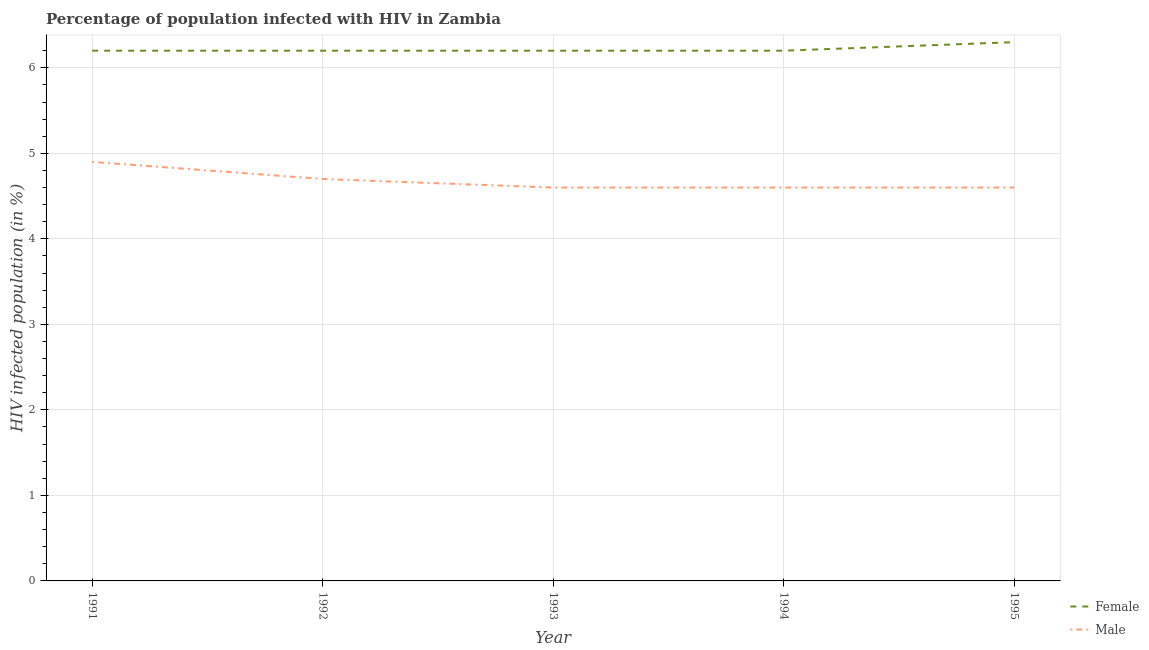How many different coloured lines are there?
Ensure brevity in your answer.  2. Does the line corresponding to percentage of females who are infected with hiv intersect with the line corresponding to percentage of males who are infected with hiv?
Your answer should be very brief. No. Is the number of lines equal to the number of legend labels?
Your answer should be compact. Yes. Across all years, what is the maximum percentage of females who are infected with hiv?
Provide a short and direct response. 6.3. Across all years, what is the minimum percentage of females who are infected with hiv?
Your response must be concise. 6.2. In which year was the percentage of males who are infected with hiv maximum?
Keep it short and to the point. 1991. What is the total percentage of females who are infected with hiv in the graph?
Provide a succinct answer. 31.1. What is the difference between the percentage of males who are infected with hiv in 1992 and that in 1994?
Provide a succinct answer. 0.1. What is the difference between the percentage of females who are infected with hiv in 1992 and the percentage of males who are infected with hiv in 1995?
Provide a short and direct response. 1.6. What is the average percentage of females who are infected with hiv per year?
Your response must be concise. 6.22. In the year 1993, what is the difference between the percentage of males who are infected with hiv and percentage of females who are infected with hiv?
Provide a short and direct response. -1.6. What is the ratio of the percentage of males who are infected with hiv in 1994 to that in 1995?
Give a very brief answer. 1. Is the percentage of males who are infected with hiv in 1994 less than that in 1995?
Your response must be concise. No. What is the difference between the highest and the second highest percentage of males who are infected with hiv?
Ensure brevity in your answer.  0.2. What is the difference between the highest and the lowest percentage of males who are infected with hiv?
Your answer should be very brief. 0.3. In how many years, is the percentage of females who are infected with hiv greater than the average percentage of females who are infected with hiv taken over all years?
Your response must be concise. 1. Is the sum of the percentage of females who are infected with hiv in 1991 and 1993 greater than the maximum percentage of males who are infected with hiv across all years?
Give a very brief answer. Yes. Does the percentage of males who are infected with hiv monotonically increase over the years?
Your answer should be compact. No. Is the percentage of females who are infected with hiv strictly greater than the percentage of males who are infected with hiv over the years?
Your answer should be very brief. Yes. How many years are there in the graph?
Ensure brevity in your answer.  5. What is the difference between two consecutive major ticks on the Y-axis?
Your answer should be compact. 1. Are the values on the major ticks of Y-axis written in scientific E-notation?
Ensure brevity in your answer.  No. Does the graph contain grids?
Offer a very short reply. Yes. Where does the legend appear in the graph?
Offer a terse response. Bottom right. How many legend labels are there?
Your answer should be compact. 2. What is the title of the graph?
Make the answer very short. Percentage of population infected with HIV in Zambia. Does "ODA received" appear as one of the legend labels in the graph?
Provide a succinct answer. No. What is the label or title of the Y-axis?
Your answer should be very brief. HIV infected population (in %). What is the HIV infected population (in %) of Female in 1991?
Offer a very short reply. 6.2. What is the HIV infected population (in %) of Male in 1991?
Give a very brief answer. 4.9. What is the HIV infected population (in %) in Female in 1994?
Provide a succinct answer. 6.2. What is the HIV infected population (in %) of Female in 1995?
Offer a terse response. 6.3. What is the HIV infected population (in %) of Male in 1995?
Provide a succinct answer. 4.6. Across all years, what is the maximum HIV infected population (in %) in Male?
Give a very brief answer. 4.9. Across all years, what is the minimum HIV infected population (in %) in Female?
Offer a very short reply. 6.2. What is the total HIV infected population (in %) of Female in the graph?
Keep it short and to the point. 31.1. What is the total HIV infected population (in %) of Male in the graph?
Your response must be concise. 23.4. What is the difference between the HIV infected population (in %) in Female in 1991 and that in 1992?
Your answer should be very brief. 0. What is the difference between the HIV infected population (in %) in Male in 1991 and that in 1992?
Your response must be concise. 0.2. What is the difference between the HIV infected population (in %) in Female in 1991 and that in 1994?
Your answer should be very brief. 0. What is the difference between the HIV infected population (in %) of Female in 1991 and that in 1995?
Provide a succinct answer. -0.1. What is the difference between the HIV infected population (in %) of Male in 1991 and that in 1995?
Make the answer very short. 0.3. What is the difference between the HIV infected population (in %) in Female in 1992 and that in 1993?
Keep it short and to the point. 0. What is the difference between the HIV infected population (in %) in Female in 1992 and that in 1994?
Your answer should be very brief. 0. What is the difference between the HIV infected population (in %) in Male in 1992 and that in 1994?
Keep it short and to the point. 0.1. What is the difference between the HIV infected population (in %) of Female in 1992 and that in 1995?
Provide a succinct answer. -0.1. What is the difference between the HIV infected population (in %) in Female in 1993 and that in 1995?
Make the answer very short. -0.1. What is the difference between the HIV infected population (in %) of Female in 1994 and that in 1995?
Offer a terse response. -0.1. What is the difference between the HIV infected population (in %) in Female in 1991 and the HIV infected population (in %) in Male in 1992?
Provide a succinct answer. 1.5. What is the difference between the HIV infected population (in %) in Female in 1991 and the HIV infected population (in %) in Male in 1994?
Provide a succinct answer. 1.6. What is the difference between the HIV infected population (in %) of Female in 1991 and the HIV infected population (in %) of Male in 1995?
Keep it short and to the point. 1.6. What is the difference between the HIV infected population (in %) of Female in 1992 and the HIV infected population (in %) of Male in 1993?
Make the answer very short. 1.6. What is the difference between the HIV infected population (in %) of Female in 1992 and the HIV infected population (in %) of Male in 1995?
Your answer should be very brief. 1.6. What is the difference between the HIV infected population (in %) of Female in 1993 and the HIV infected population (in %) of Male in 1994?
Your response must be concise. 1.6. What is the difference between the HIV infected population (in %) of Female in 1993 and the HIV infected population (in %) of Male in 1995?
Keep it short and to the point. 1.6. What is the difference between the HIV infected population (in %) of Female in 1994 and the HIV infected population (in %) of Male in 1995?
Give a very brief answer. 1.6. What is the average HIV infected population (in %) in Female per year?
Give a very brief answer. 6.22. What is the average HIV infected population (in %) of Male per year?
Give a very brief answer. 4.68. In the year 1992, what is the difference between the HIV infected population (in %) in Female and HIV infected population (in %) in Male?
Make the answer very short. 1.5. In the year 1994, what is the difference between the HIV infected population (in %) of Female and HIV infected population (in %) of Male?
Give a very brief answer. 1.6. What is the ratio of the HIV infected population (in %) of Female in 1991 to that in 1992?
Provide a succinct answer. 1. What is the ratio of the HIV infected population (in %) in Male in 1991 to that in 1992?
Provide a short and direct response. 1.04. What is the ratio of the HIV infected population (in %) of Male in 1991 to that in 1993?
Your answer should be very brief. 1.07. What is the ratio of the HIV infected population (in %) of Female in 1991 to that in 1994?
Provide a short and direct response. 1. What is the ratio of the HIV infected population (in %) in Male in 1991 to that in 1994?
Provide a short and direct response. 1.07. What is the ratio of the HIV infected population (in %) of Female in 1991 to that in 1995?
Your response must be concise. 0.98. What is the ratio of the HIV infected population (in %) of Male in 1991 to that in 1995?
Offer a very short reply. 1.07. What is the ratio of the HIV infected population (in %) of Male in 1992 to that in 1993?
Keep it short and to the point. 1.02. What is the ratio of the HIV infected population (in %) in Female in 1992 to that in 1994?
Ensure brevity in your answer.  1. What is the ratio of the HIV infected population (in %) in Male in 1992 to that in 1994?
Offer a terse response. 1.02. What is the ratio of the HIV infected population (in %) of Female in 1992 to that in 1995?
Give a very brief answer. 0.98. What is the ratio of the HIV infected population (in %) in Male in 1992 to that in 1995?
Provide a short and direct response. 1.02. What is the ratio of the HIV infected population (in %) in Female in 1993 to that in 1994?
Your answer should be very brief. 1. What is the ratio of the HIV infected population (in %) of Female in 1993 to that in 1995?
Keep it short and to the point. 0.98. What is the ratio of the HIV infected population (in %) of Female in 1994 to that in 1995?
Your answer should be compact. 0.98. What is the ratio of the HIV infected population (in %) of Male in 1994 to that in 1995?
Offer a terse response. 1. What is the difference between the highest and the second highest HIV infected population (in %) in Male?
Offer a terse response. 0.2. What is the difference between the highest and the lowest HIV infected population (in %) of Female?
Keep it short and to the point. 0.1. 